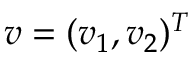<formula> <loc_0><loc_0><loc_500><loc_500>v = ( v _ { 1 } , v _ { 2 } ) ^ { T }</formula> 